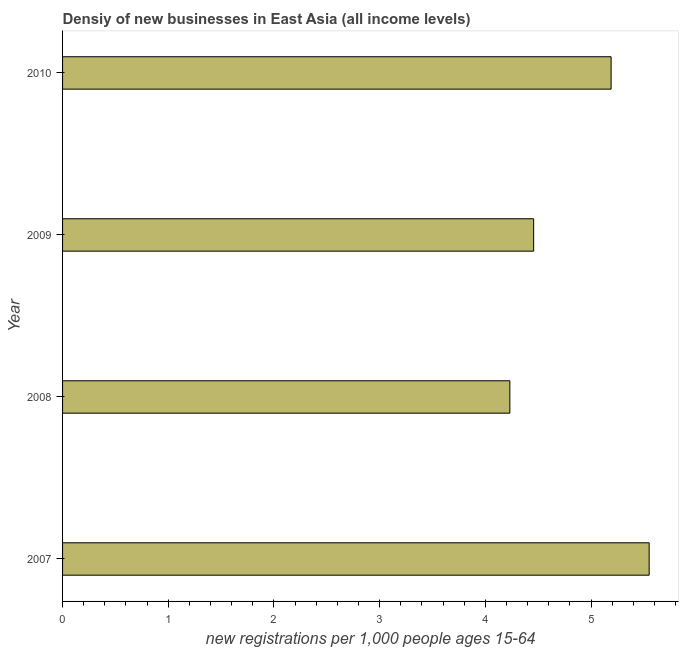Does the graph contain grids?
Your answer should be very brief. No. What is the title of the graph?
Provide a short and direct response. Densiy of new businesses in East Asia (all income levels). What is the label or title of the X-axis?
Make the answer very short. New registrations per 1,0 people ages 15-64. What is the density of new business in 2007?
Provide a succinct answer. 5.55. Across all years, what is the maximum density of new business?
Offer a very short reply. 5.55. Across all years, what is the minimum density of new business?
Your answer should be compact. 4.23. In which year was the density of new business maximum?
Ensure brevity in your answer.  2007. What is the sum of the density of new business?
Make the answer very short. 19.43. What is the difference between the density of new business in 2008 and 2010?
Your response must be concise. -0.96. What is the average density of new business per year?
Offer a terse response. 4.86. What is the median density of new business?
Your answer should be very brief. 4.82. Do a majority of the years between 2008 and 2010 (inclusive) have density of new business greater than 3.6 ?
Provide a short and direct response. Yes. What is the ratio of the density of new business in 2007 to that in 2010?
Ensure brevity in your answer.  1.07. Is the density of new business in 2007 less than that in 2009?
Offer a very short reply. No. Is the difference between the density of new business in 2007 and 2008 greater than the difference between any two years?
Give a very brief answer. Yes. What is the difference between the highest and the second highest density of new business?
Keep it short and to the point. 0.36. Is the sum of the density of new business in 2007 and 2009 greater than the maximum density of new business across all years?
Offer a very short reply. Yes. What is the difference between the highest and the lowest density of new business?
Your response must be concise. 1.32. In how many years, is the density of new business greater than the average density of new business taken over all years?
Your response must be concise. 2. How many years are there in the graph?
Provide a succinct answer. 4. Are the values on the major ticks of X-axis written in scientific E-notation?
Your answer should be very brief. No. What is the new registrations per 1,000 people ages 15-64 of 2007?
Your answer should be very brief. 5.55. What is the new registrations per 1,000 people ages 15-64 in 2008?
Your answer should be compact. 4.23. What is the new registrations per 1,000 people ages 15-64 of 2009?
Your answer should be very brief. 4.46. What is the new registrations per 1,000 people ages 15-64 in 2010?
Make the answer very short. 5.19. What is the difference between the new registrations per 1,000 people ages 15-64 in 2007 and 2008?
Offer a very short reply. 1.32. What is the difference between the new registrations per 1,000 people ages 15-64 in 2007 and 2009?
Your answer should be very brief. 1.09. What is the difference between the new registrations per 1,000 people ages 15-64 in 2007 and 2010?
Make the answer very short. 0.36. What is the difference between the new registrations per 1,000 people ages 15-64 in 2008 and 2009?
Your answer should be compact. -0.23. What is the difference between the new registrations per 1,000 people ages 15-64 in 2008 and 2010?
Your answer should be compact. -0.96. What is the difference between the new registrations per 1,000 people ages 15-64 in 2009 and 2010?
Ensure brevity in your answer.  -0.73. What is the ratio of the new registrations per 1,000 people ages 15-64 in 2007 to that in 2008?
Ensure brevity in your answer.  1.31. What is the ratio of the new registrations per 1,000 people ages 15-64 in 2007 to that in 2009?
Provide a short and direct response. 1.25. What is the ratio of the new registrations per 1,000 people ages 15-64 in 2007 to that in 2010?
Make the answer very short. 1.07. What is the ratio of the new registrations per 1,000 people ages 15-64 in 2008 to that in 2009?
Offer a very short reply. 0.95. What is the ratio of the new registrations per 1,000 people ages 15-64 in 2008 to that in 2010?
Offer a very short reply. 0.81. What is the ratio of the new registrations per 1,000 people ages 15-64 in 2009 to that in 2010?
Your answer should be very brief. 0.86. 